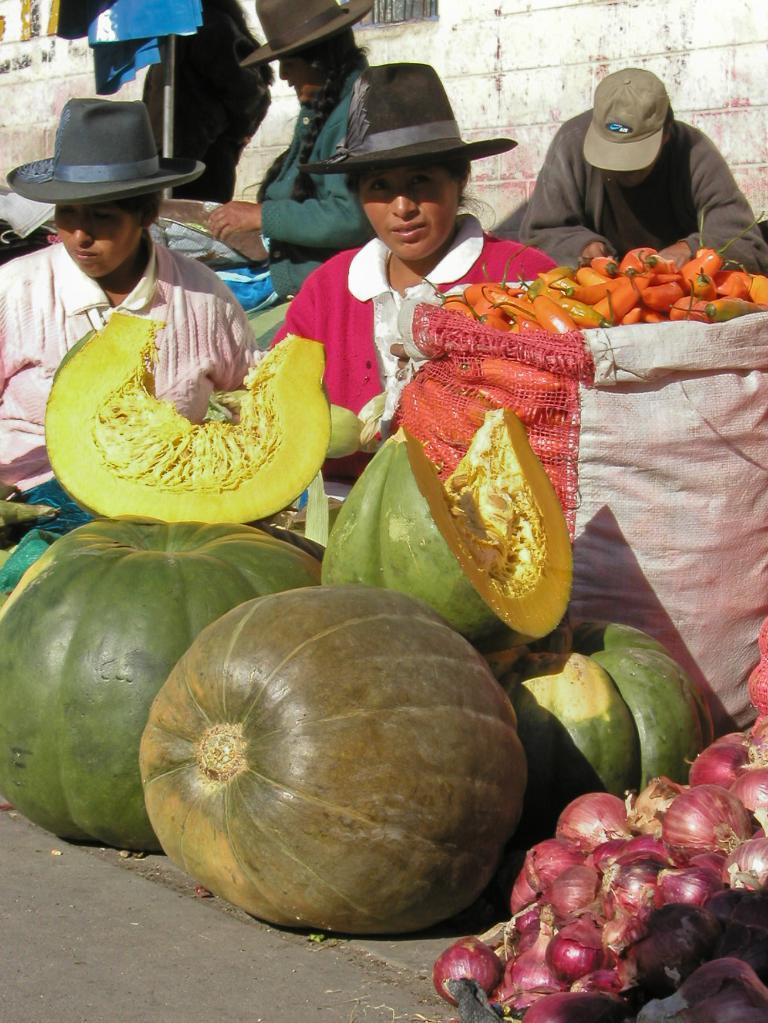What is the main subject of the image? The main subject of the image is a group of people. What are the people wearing in the image? The people are wearing caps in the image. What can be seen in front of the group of people? There are vegetables in front of the group of people. What type of banana is being transported by the group of people in the image? There is no banana present in the image, nor is there any indication of transportation. 